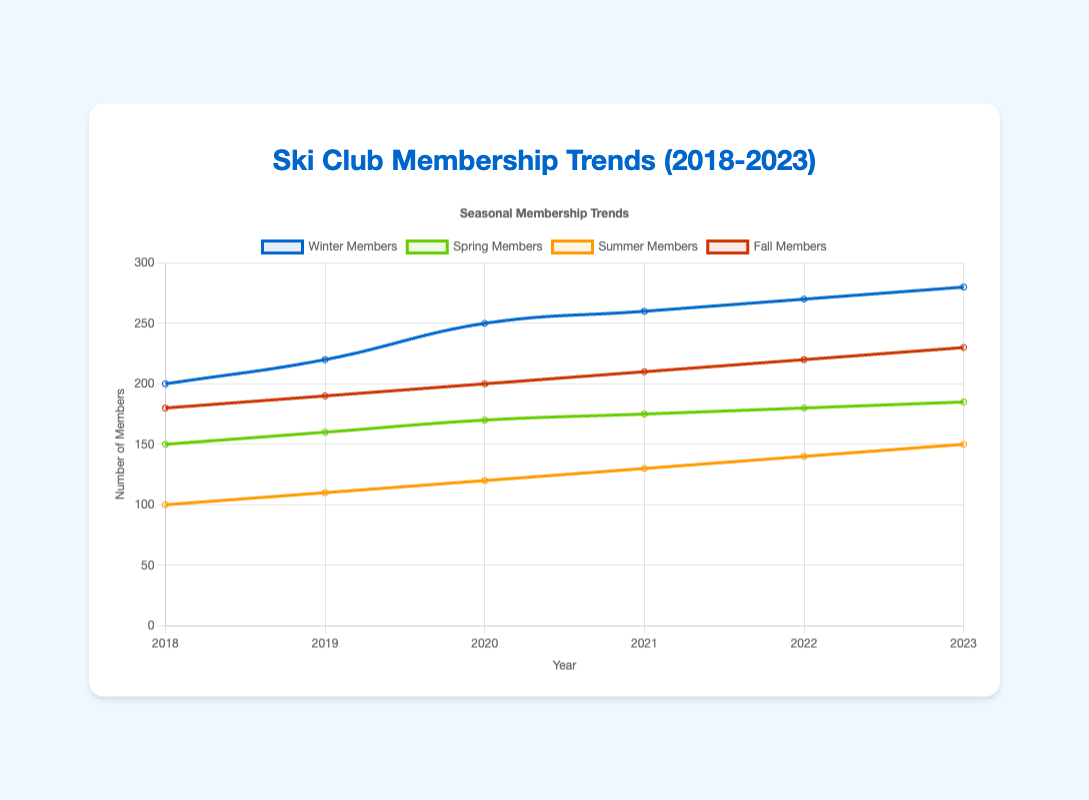What is the total number of members in 2023 combining all seasons? To find the total number of members in 2023, sum the membership numbers of all four seasons: Winter (280) + Spring (185) + Summer (150) + Fall (230). The total is 280 + 185 + 150 + 230 = 845.
Answer: 845 Which season had the lowest increment in membership from 2018 to 2023? To find this, calculate the difference in membership for each season between 2023 and 2018: Winter: 280 - 200 = 80, Spring: 185 - 150 = 35, Summer: 150 - 100 = 50, Fall: 230 - 180 = 50. The Spring season had the lowest increment of 35 members.
Answer: Spring What is the average number of winter members from 2018 to 2023? To find the average, sum the winter membership numbers and divide by the total years. The sum is 200 + 220 + 250 + 260 + 270 + 280 = 1480. The average is 1480/6 ≈ 247.
Answer: 247 Which year showed the highest increase in fall membership compared to the previous year? Calculate the yearly increase for fall membership: 2019: 190 - 180 = 10, 2020: 200 - 190 = 10, 2021: 210 - 200 = 10, 2022: 220 - 210 = 10, 2023: 230 - 220 = 10. The largest increase was from 2018 to 2019, 2019 to 2020, 2020 to 2021, 2021 to 2022, and 2022 to 2023, each with 10 members.
Answer: All increments are equal In which year were summer members exactly half of winter members? Summer members in 2018-2023 are: 100, 110, 120, 130, 140, 150. Winter members are: 200, 220, 250, 260, 270, 280. Check where summer members are half of winter members: 100 is half of 200 (2018). None of other years match this condition.
Answer: 2018 Which season has the most frequent highest membership numbers over the years? Count the number of times each season has the highest membership in each year: Winter had the most members in all years (2018–2023). Other seasons had lower memberships comparatively.
Answer: Winter What is the difference in summer membership between 2021 and 2023? Subtract the summer members in 2021 from the summer members in 2023: 150 - 130 = 20. The difference is 20.
Answer: 20 Which season shows the most consistent growth in membership over the years? To determine consistent growth, check year-over-year increase: Winter increases consistently by about 10 or more each year; other seasons show a steadier, but smaller, increase.
Answer: Winter What is the combined total membership for winter and spring in 2020? Sum the winter and spring members in 2020: Winter (250) + Spring (170) = 250 + 170 = 420.
Answer: 420 